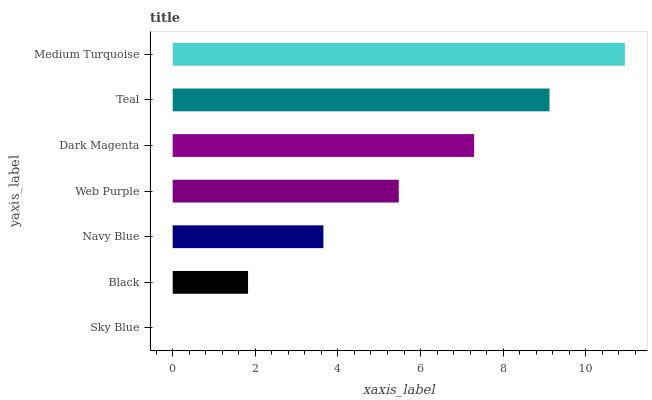Is Sky Blue the minimum?
Answer yes or no. Yes. Is Medium Turquoise the maximum?
Answer yes or no. Yes. Is Black the minimum?
Answer yes or no. No. Is Black the maximum?
Answer yes or no. No. Is Black greater than Sky Blue?
Answer yes or no. Yes. Is Sky Blue less than Black?
Answer yes or no. Yes. Is Sky Blue greater than Black?
Answer yes or no. No. Is Black less than Sky Blue?
Answer yes or no. No. Is Web Purple the high median?
Answer yes or no. Yes. Is Web Purple the low median?
Answer yes or no. Yes. Is Sky Blue the high median?
Answer yes or no. No. Is Navy Blue the low median?
Answer yes or no. No. 